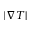Convert formula to latex. <formula><loc_0><loc_0><loc_500><loc_500>| \nabla T |</formula> 